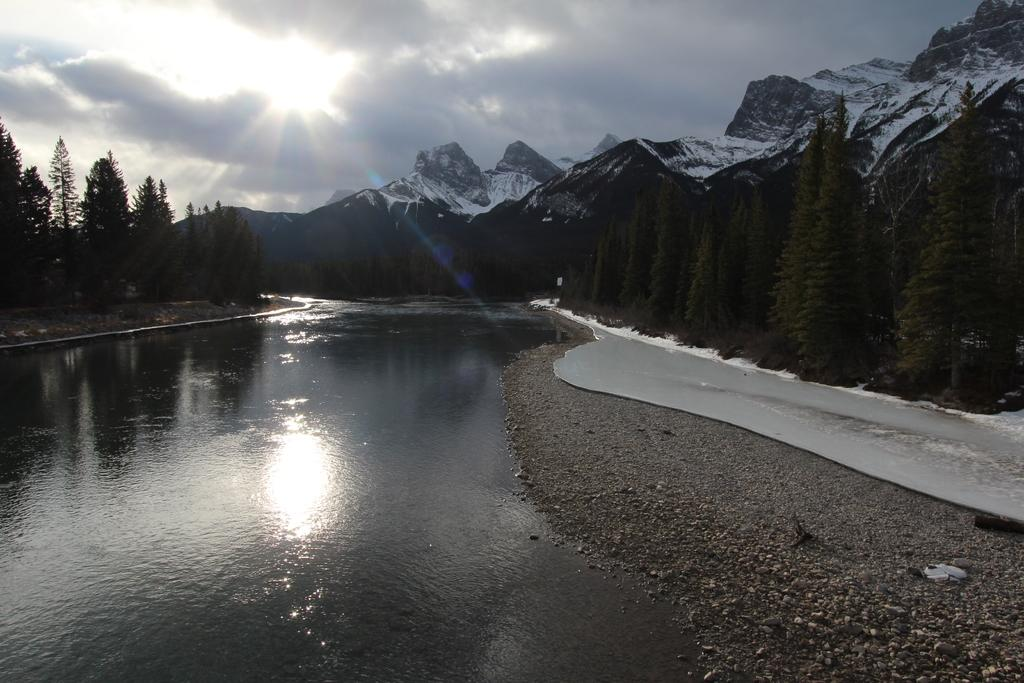What is present in the image that is related to a natural body of water? There is water in the image. What type of vegetation can be seen in the image? There are trees in the image. What geographical feature is visible in the image? There are mountains in the image. What can be seen in the background of the image? The sky is visible in the background of the image. What celestial body is observable in the sky? The sun is observable in the sky. What type of arch can be seen in the image? There is no arch present in the image. Is the sink visible in the image? There is no sink present in the image. 